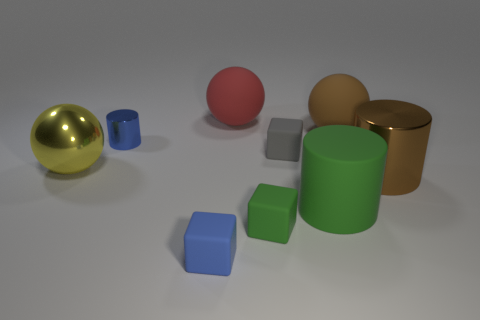Is there anything else that is the same color as the large metallic cylinder?
Your response must be concise. Yes. What is the size of the matte block that is the same color as the matte cylinder?
Make the answer very short. Small. Is the number of gray objects behind the brown sphere greater than the number of large red rubber spheres?
Make the answer very short. No. Does the small gray object have the same shape as the tiny blue thing that is in front of the big yellow thing?
Ensure brevity in your answer.  Yes. What number of green objects have the same size as the gray block?
Your response must be concise. 1. There is a blue shiny thing that is left of the large matte object to the left of the tiny green matte thing; how many big red matte balls are on the right side of it?
Provide a short and direct response. 1. Is the number of large red matte things that are in front of the blue cube the same as the number of large metal spheres that are on the left side of the big brown cylinder?
Your response must be concise. No. What number of tiny blue things are the same shape as the large red rubber thing?
Provide a short and direct response. 0. Are there any tiny red objects made of the same material as the large brown ball?
Your response must be concise. No. There is a small thing that is the same color as the matte cylinder; what shape is it?
Your answer should be compact. Cube. 